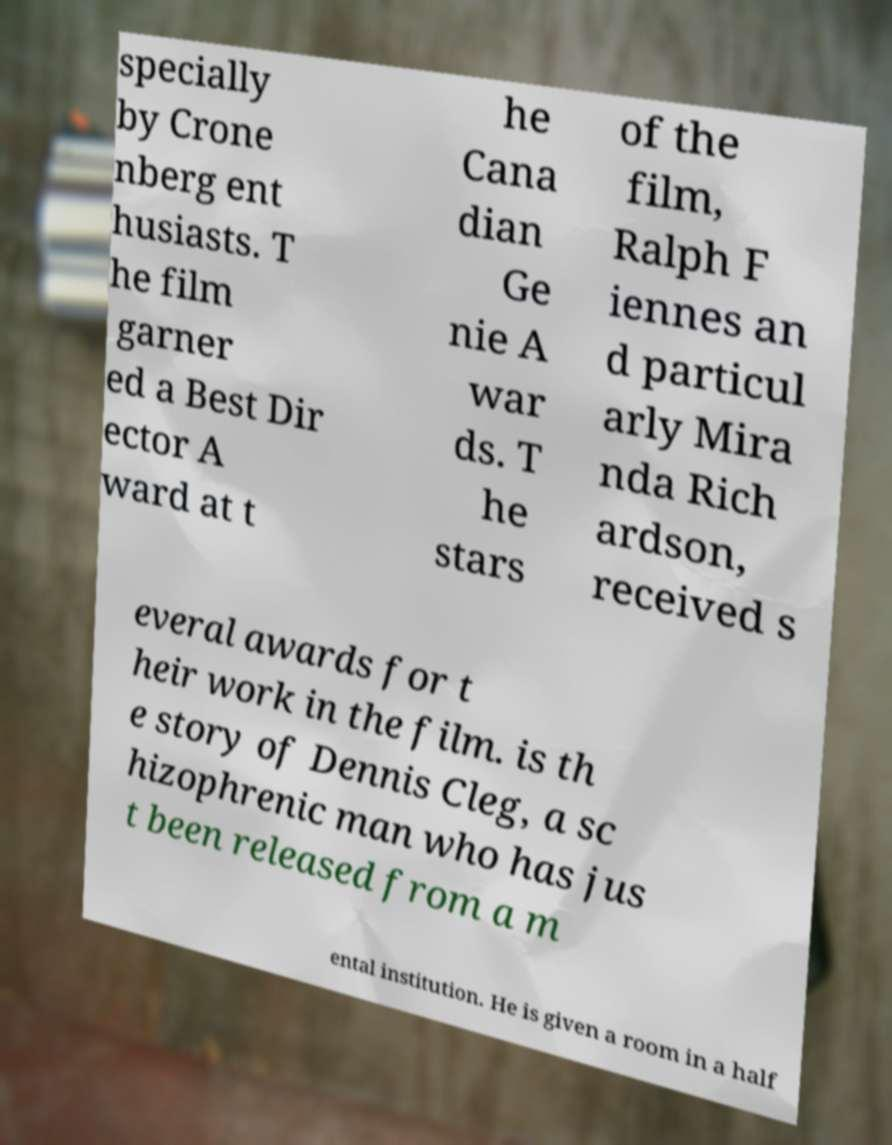I need the written content from this picture converted into text. Can you do that? specially by Crone nberg ent husiasts. T he film garner ed a Best Dir ector A ward at t he Cana dian Ge nie A war ds. T he stars of the film, Ralph F iennes an d particul arly Mira nda Rich ardson, received s everal awards for t heir work in the film. is th e story of Dennis Cleg, a sc hizophrenic man who has jus t been released from a m ental institution. He is given a room in a half 